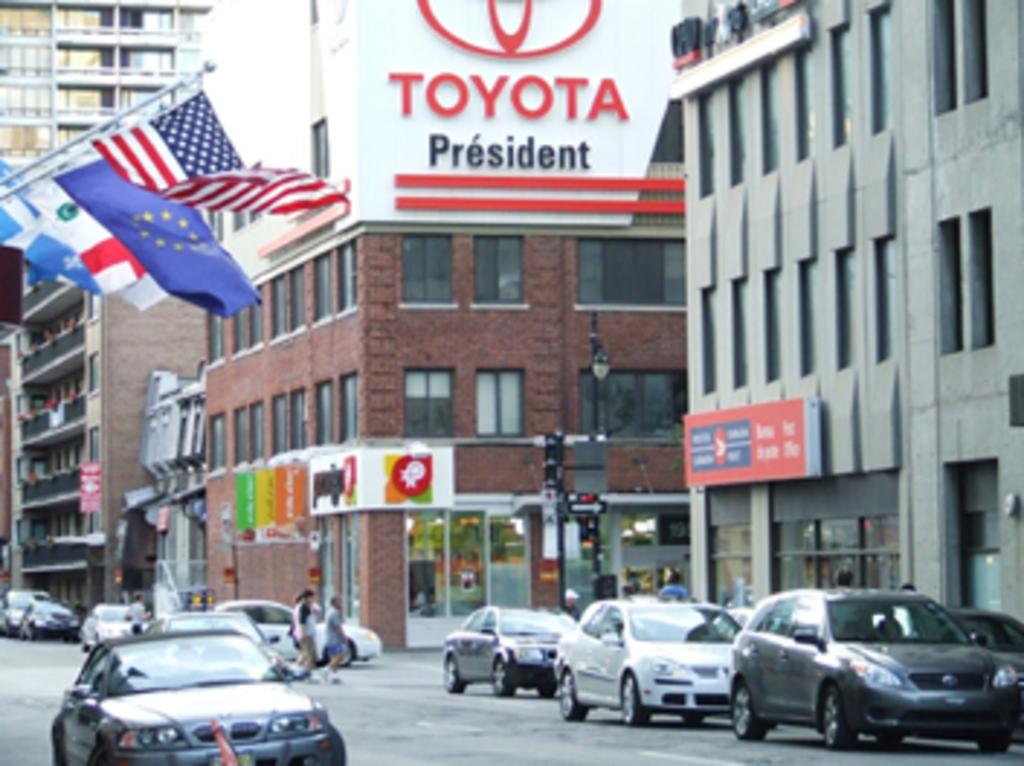What type of structures can be seen in the image? There are buildings in the image. What is the large sign with advertisements called? There is a hoarding in the image. What type of decorations or symbols are present in the image? There are flags in the image. What are the flat, rectangular objects used for in the image? There are boards in the image, which can be used for various purposes such as displaying information or advertisements. What can be seen illuminating the area in the image? There are lights in the image. What is the tall, thin object in the image used for? There is a pole in the image, which can be used for various purposes such as holding signs, lights, or other objects. Who or what is present in the image? There are people in the image. What type of transportation is visible on the road in the image? There are vehicles on the road in the image. What type of wound can be seen on the person in the image? There is no person with a wound present in the image. What tool is being used to roll the vehicles in the image? There is no tool or person rolling vehicles in the image; the vehicles are stationary on the road. 